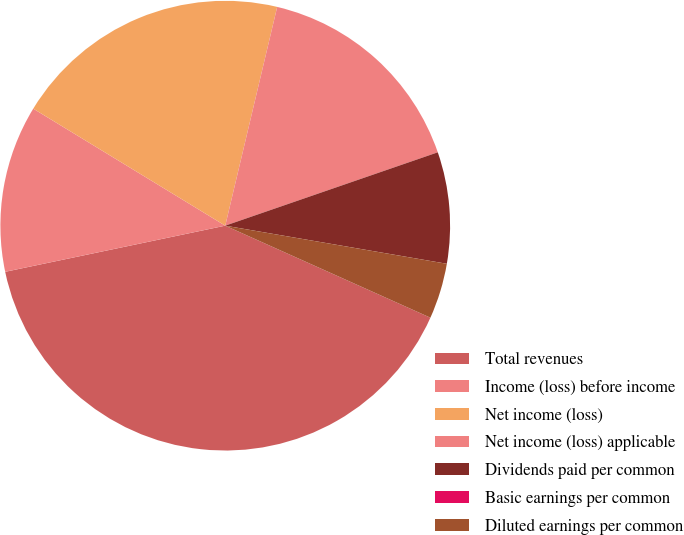Convert chart. <chart><loc_0><loc_0><loc_500><loc_500><pie_chart><fcel>Total revenues<fcel>Income (loss) before income<fcel>Net income (loss)<fcel>Net income (loss) applicable<fcel>Dividends paid per common<fcel>Basic earnings per common<fcel>Diluted earnings per common<nl><fcel>40.0%<fcel>12.0%<fcel>20.0%<fcel>16.0%<fcel>8.0%<fcel>0.0%<fcel>4.0%<nl></chart> 